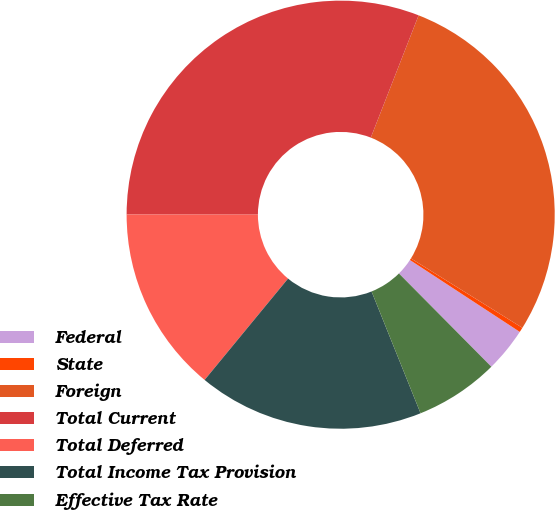Convert chart. <chart><loc_0><loc_0><loc_500><loc_500><pie_chart><fcel>Federal<fcel>State<fcel>Foreign<fcel>Total Current<fcel>Total Deferred<fcel>Total Income Tax Provision<fcel>Effective Tax Rate<nl><fcel>3.35%<fcel>0.36%<fcel>27.93%<fcel>30.92%<fcel>14.05%<fcel>17.05%<fcel>6.34%<nl></chart> 